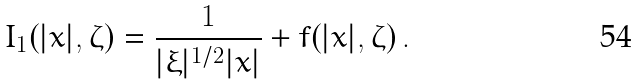<formula> <loc_0><loc_0><loc_500><loc_500>I _ { 1 } ( | x | , \zeta ) = \frac { 1 } { | \xi | ^ { 1 / 2 } | x | } + f ( | x | , \zeta ) \, .</formula> 